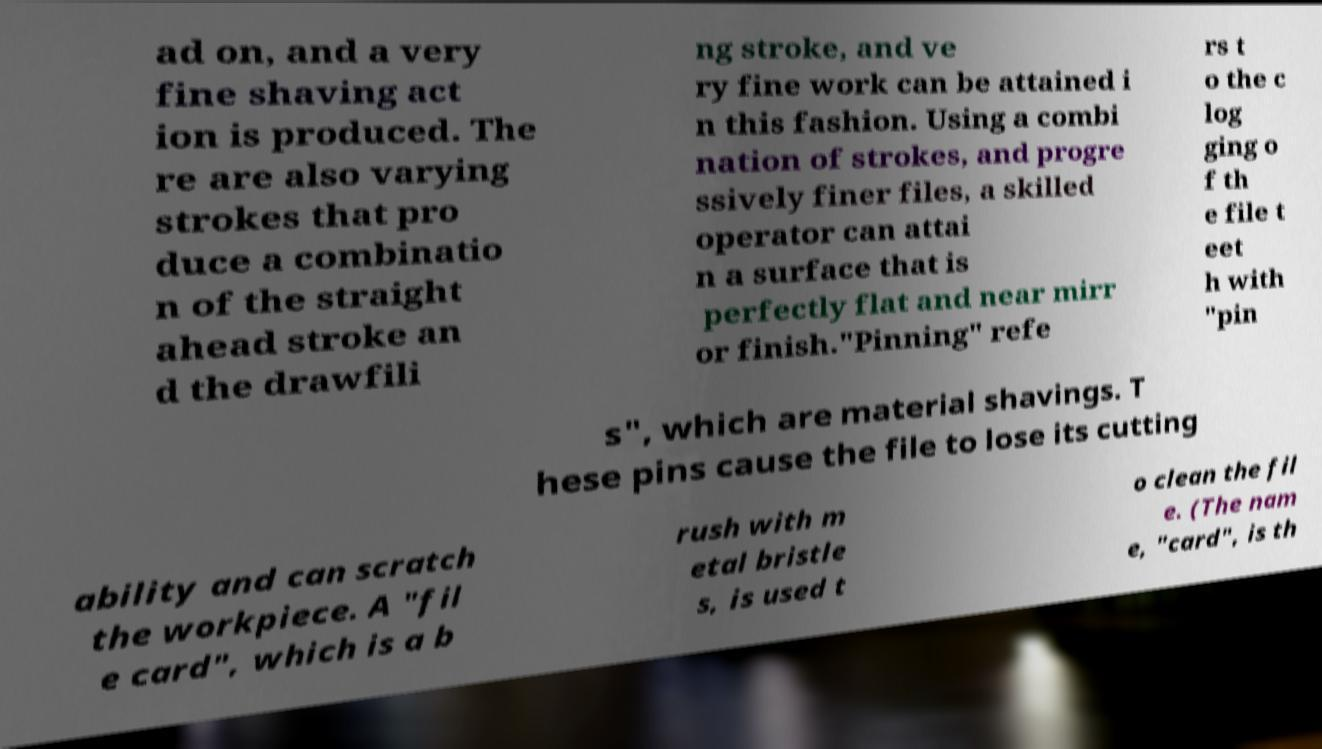Can you read and provide the text displayed in the image?This photo seems to have some interesting text. Can you extract and type it out for me? ad on, and a very fine shaving act ion is produced. The re are also varying strokes that pro duce a combinatio n of the straight ahead stroke an d the drawfili ng stroke, and ve ry fine work can be attained i n this fashion. Using a combi nation of strokes, and progre ssively finer files, a skilled operator can attai n a surface that is perfectly flat and near mirr or finish."Pinning" refe rs t o the c log ging o f th e file t eet h with "pin s", which are material shavings. T hese pins cause the file to lose its cutting ability and can scratch the workpiece. A "fil e card", which is a b rush with m etal bristle s, is used t o clean the fil e. (The nam e, "card", is th 